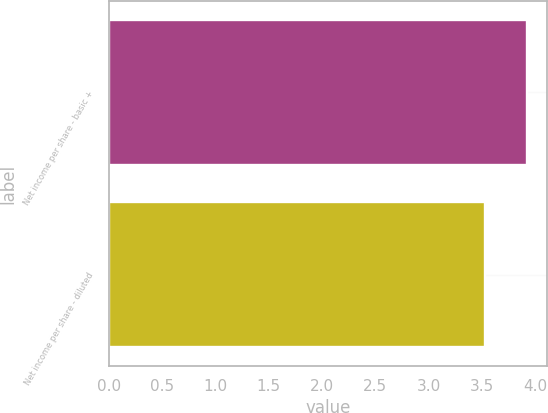Convert chart. <chart><loc_0><loc_0><loc_500><loc_500><bar_chart><fcel>Net income per share - basic +<fcel>Net income per share - diluted<nl><fcel>3.92<fcel>3.53<nl></chart> 